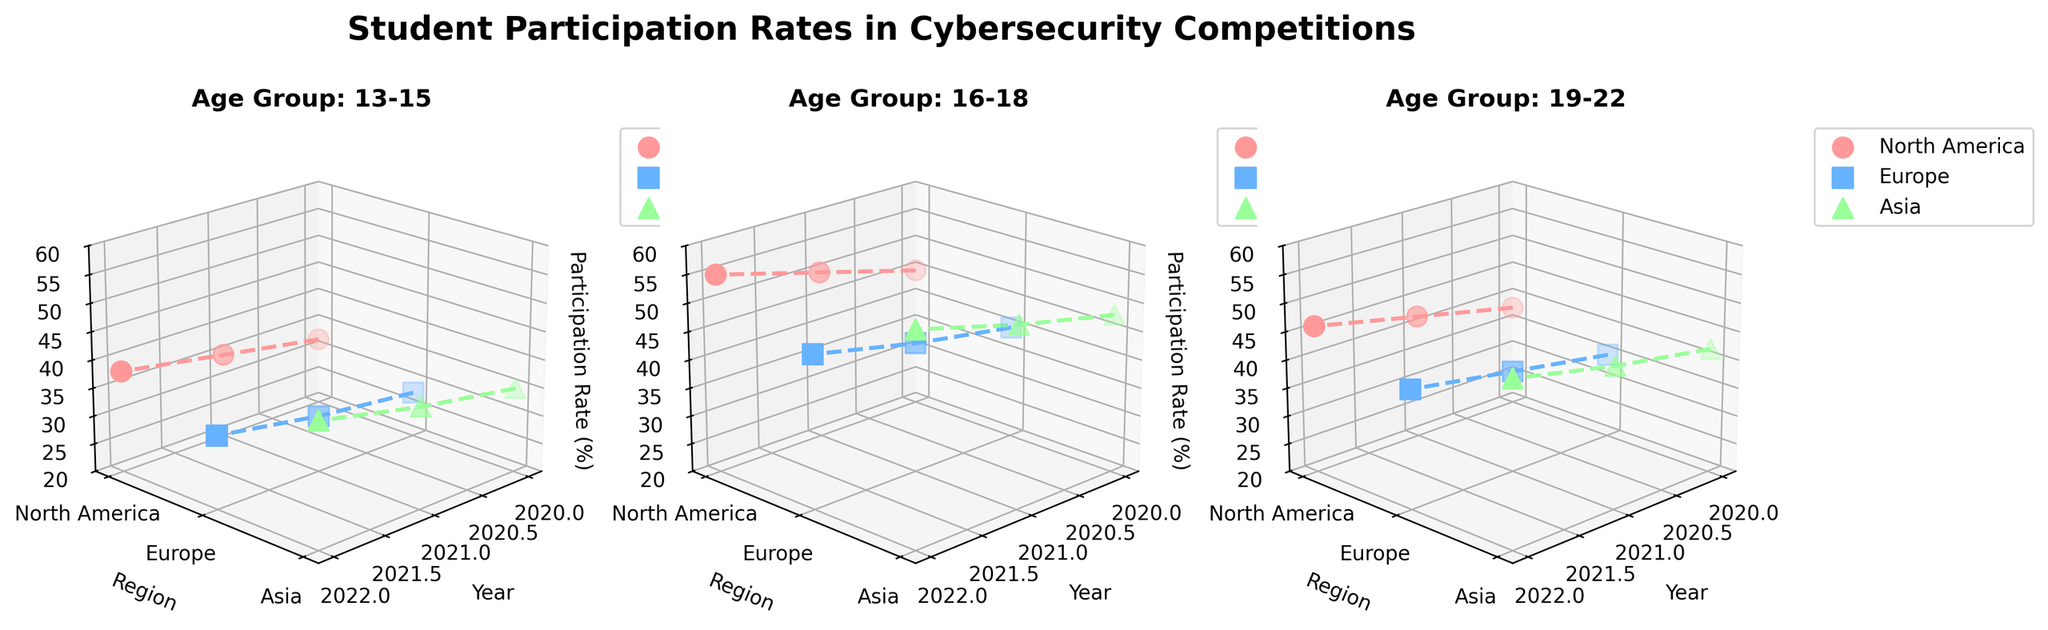What is the title of the plot? The title is displayed at the top of the plot and it reads "Student Participation Rates in Cybersecurity Competitions".
Answer: Student Participation Rates in Cybersecurity Competitions Which age group has the highest participation rate in North America in 2022? From the subplot for each age group, look at the participation rate for North America in 2022. For 13-15, it's 38%; for 16-18, it's 55%; and for 19-22, it's 46%. The highest is for the 16-18 age group.
Answer: 16-18 How many regions are compared in each subplot? Each subplot has three regions marked by different colors. By counting distinct regions in any subplot, we see North America, Europe, and Asia.
Answer: 3 Between which two years did the 13-15 age group in Europe see the largest increase in participation rate? Examine the participation rates for the 13-15 age group in Europe from year to year: 28% in 2020, 30% in 2021, and 33% in 2022. The largest increase is between 2021 and 2022 (33 - 30 = 3).
Answer: 2021 and 2022 Which region has the lowest participation rate in the 19-22 age group in 2020? By looking at the subplot for the 19-22 age group and comparing the participation rates for 2020: North America has 38%, Europe has 35%, and Asia has 42%. The lowest rate is in Europe.
Answer: Europe What is the trend in participation rates for the 16-18 age group in Asia from 2020 to 2022? Observing the 16-18 age group in the Asia region, the participation rates go from 48% in 2020 to 52% in 2021 and 57% in 2022. This reveals an upward trend.
Answer: Increasing Between 2021 and 2022, which age group in North America saw the smallest increase in participation rate? Compare the increment in participation rate for each age group in North America between 2021 and 2022: for 13-15, it's 3% (38-35); for 16-18, it's 5% (55-50); for 19-22, it's 4% (46-42). The smallest increase is for the 13-15 age group.
Answer: 13-15 Is there any region where all age groups show a consistent increasing trend in participation rates from 2020 to 2022? Check each region for all age groups. In North America, all age groups increase each year. In Europe and Asia, this consistency also holds. However, overall, Asia shows the most significant rise across all age groups, indicating consistency.
Answer: Yes, Asia Which age group and region combination had the highest participation rate in any single year? Examine all the subplots. The highest value is for 16-18 age group in Asia in 2022 with a participation rate of 57%.
Answer: 16-18 age group in Asia in 2022 